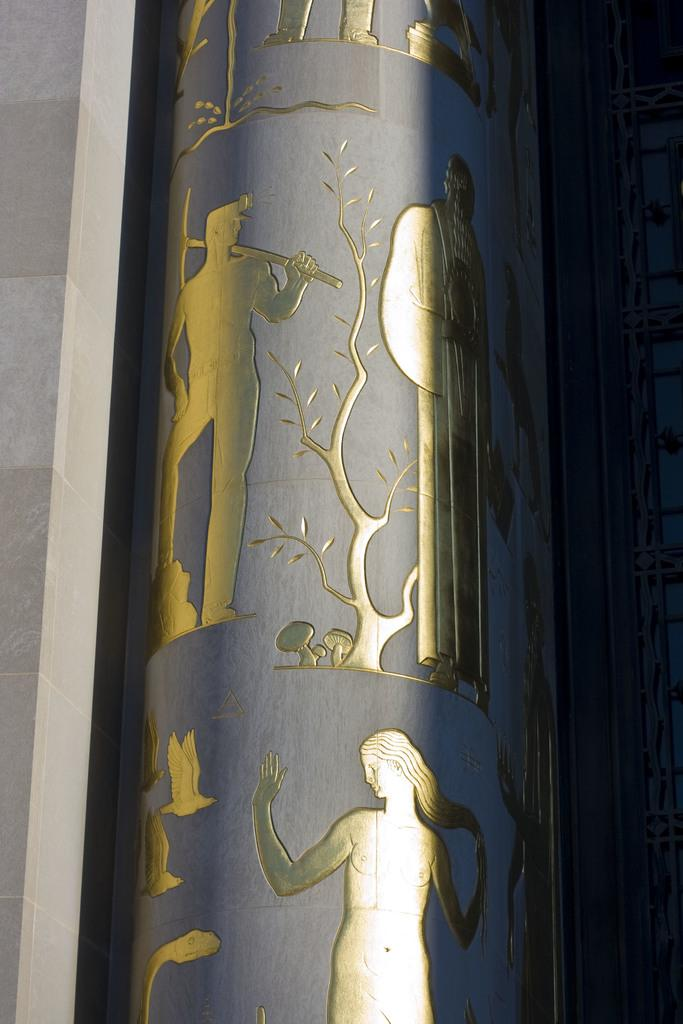What type of structures are depicted on the wall in the image? There is a structure of a woman and a structure of a man on the wall. How is the structure of the man depicted? The structure of the man appears to be tree-shaped. What type of noise can be heard coming from the pizzas in the image? There are no pizzas present in the image, so it's not possible to determine what, if any, noise might be heard. 